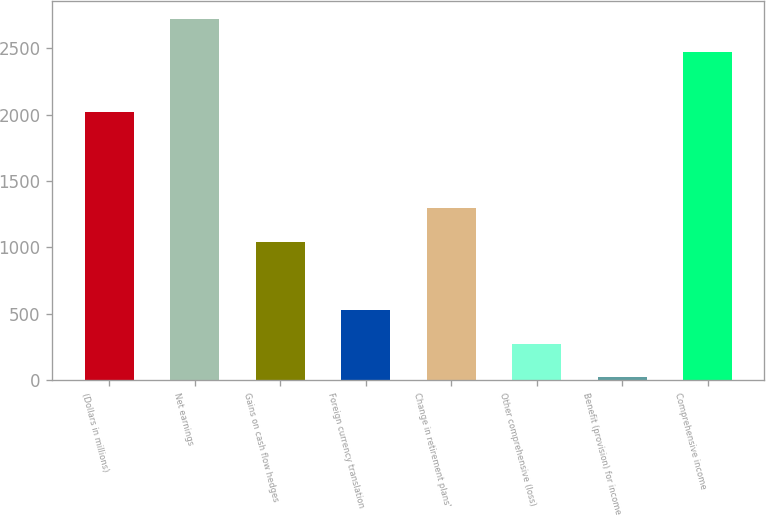Convert chart to OTSL. <chart><loc_0><loc_0><loc_500><loc_500><bar_chart><fcel>(Dollars in millions)<fcel>Net earnings<fcel>Gains on cash flow hedges<fcel>Foreign currency translation<fcel>Change in retirement plans'<fcel>Other comprehensive (loss)<fcel>Benefit (provision) for income<fcel>Comprehensive income<nl><fcel>2016<fcel>2723.4<fcel>1039.6<fcel>528.8<fcel>1295<fcel>273.4<fcel>18<fcel>2468<nl></chart> 